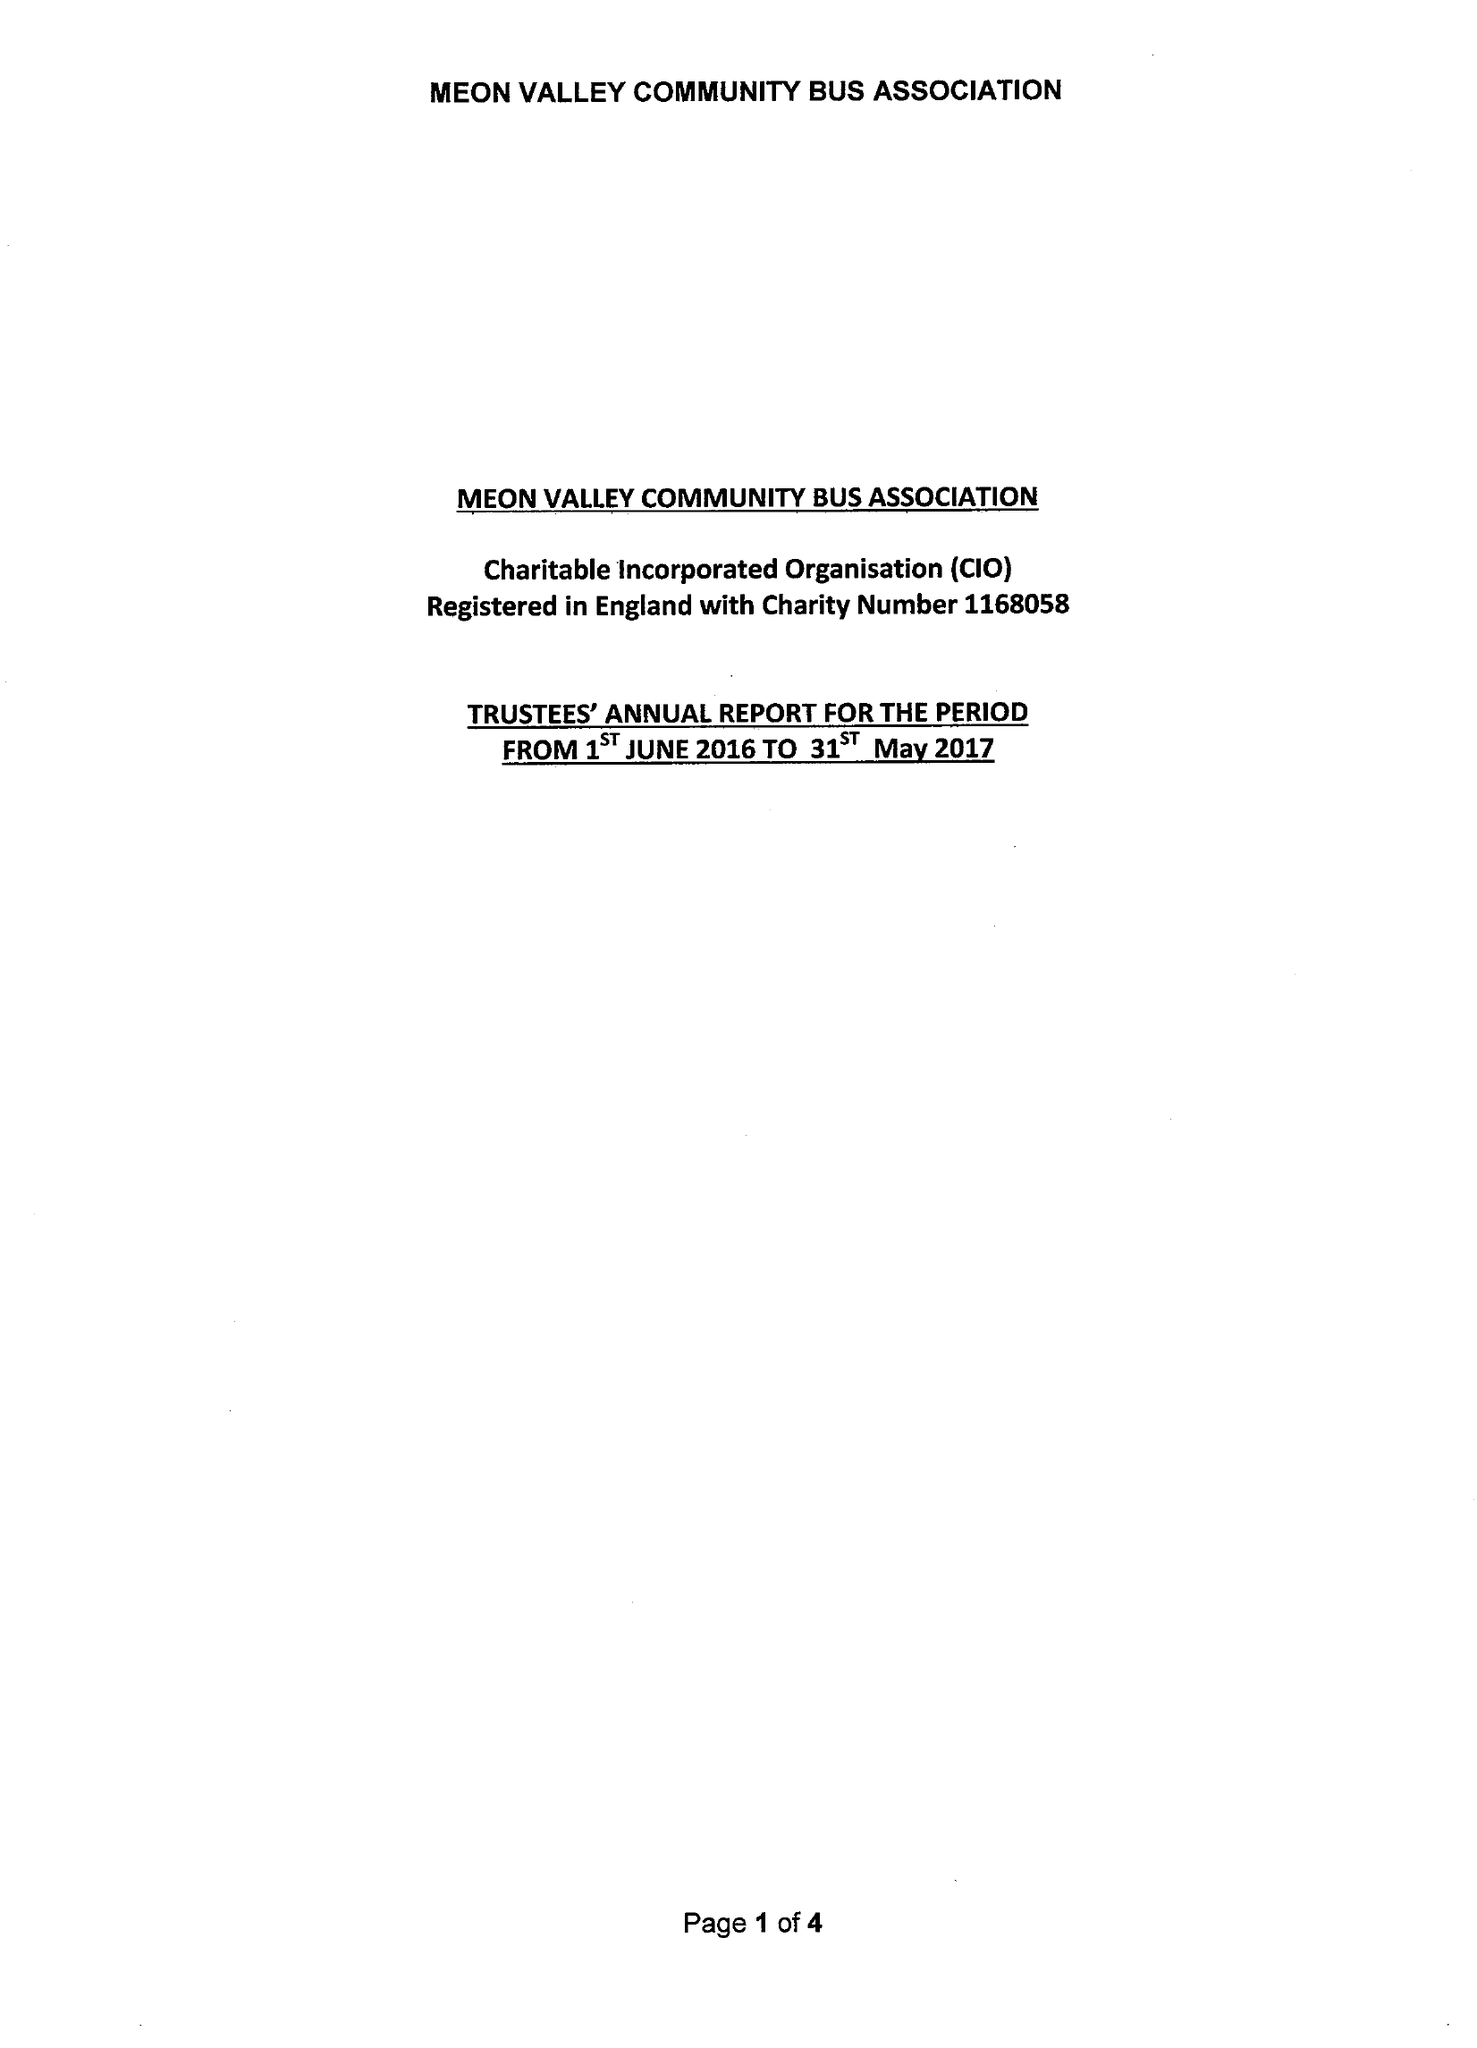What is the value for the charity_name?
Answer the question using a single word or phrase. Meon Valley Community Bus Association 